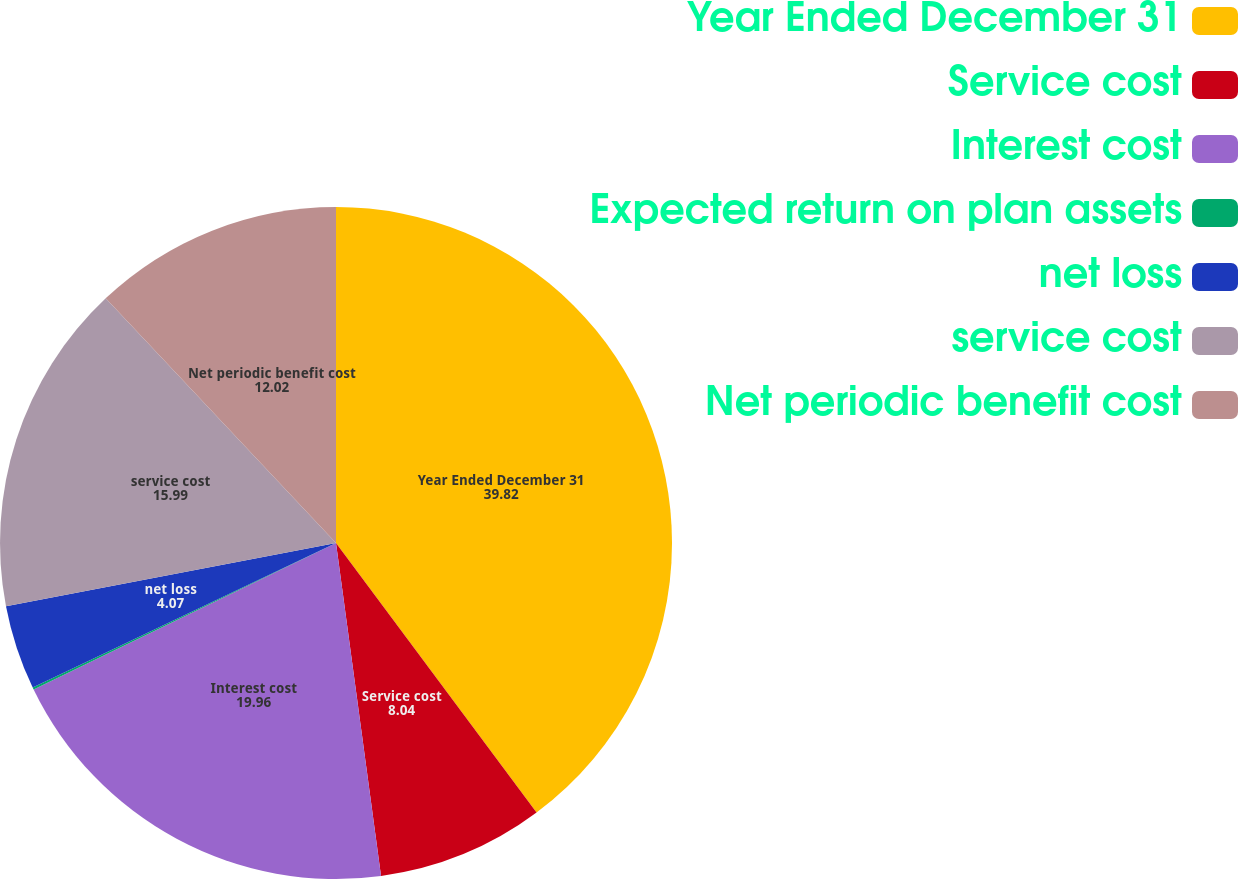Convert chart to OTSL. <chart><loc_0><loc_0><loc_500><loc_500><pie_chart><fcel>Year Ended December 31<fcel>Service cost<fcel>Interest cost<fcel>Expected return on plan assets<fcel>net loss<fcel>service cost<fcel>Net periodic benefit cost<nl><fcel>39.82%<fcel>8.04%<fcel>19.96%<fcel>0.1%<fcel>4.07%<fcel>15.99%<fcel>12.02%<nl></chart> 